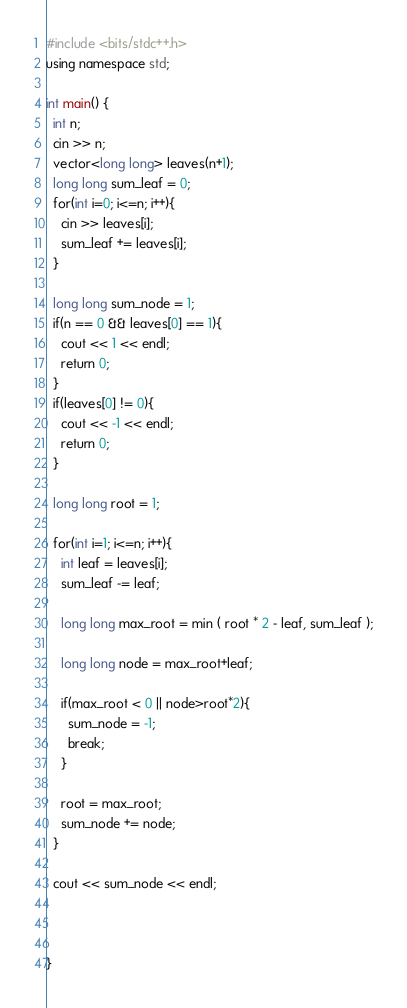Convert code to text. <code><loc_0><loc_0><loc_500><loc_500><_C++_>#include <bits/stdc++.h>
using namespace std;

int main() {
  int n;
  cin >> n;
  vector<long long> leaves(n+1);
  long long sum_leaf = 0;
  for(int i=0; i<=n; i++){
    cin >> leaves[i];
    sum_leaf += leaves[i];
  }
  
  long long sum_node = 1;
  if(n == 0 && leaves[0] == 1){
    cout << 1 << endl;
    return 0;
  }
  if(leaves[0] != 0){
    cout << -1 << endl;
    return 0;
  }
  
  long long root = 1;
  
  for(int i=1; i<=n; i++){
    int leaf = leaves[i];
    sum_leaf -= leaf;
    
    long long max_root = min ( root * 2 - leaf, sum_leaf );
    
    long long node = max_root+leaf;
    
    if(max_root < 0 || node>root*2){
      sum_node = -1;
      break;
    }
    
    root = max_root;
    sum_node += node;
  }
  
  cout << sum_node << endl;
  
  

}</code> 